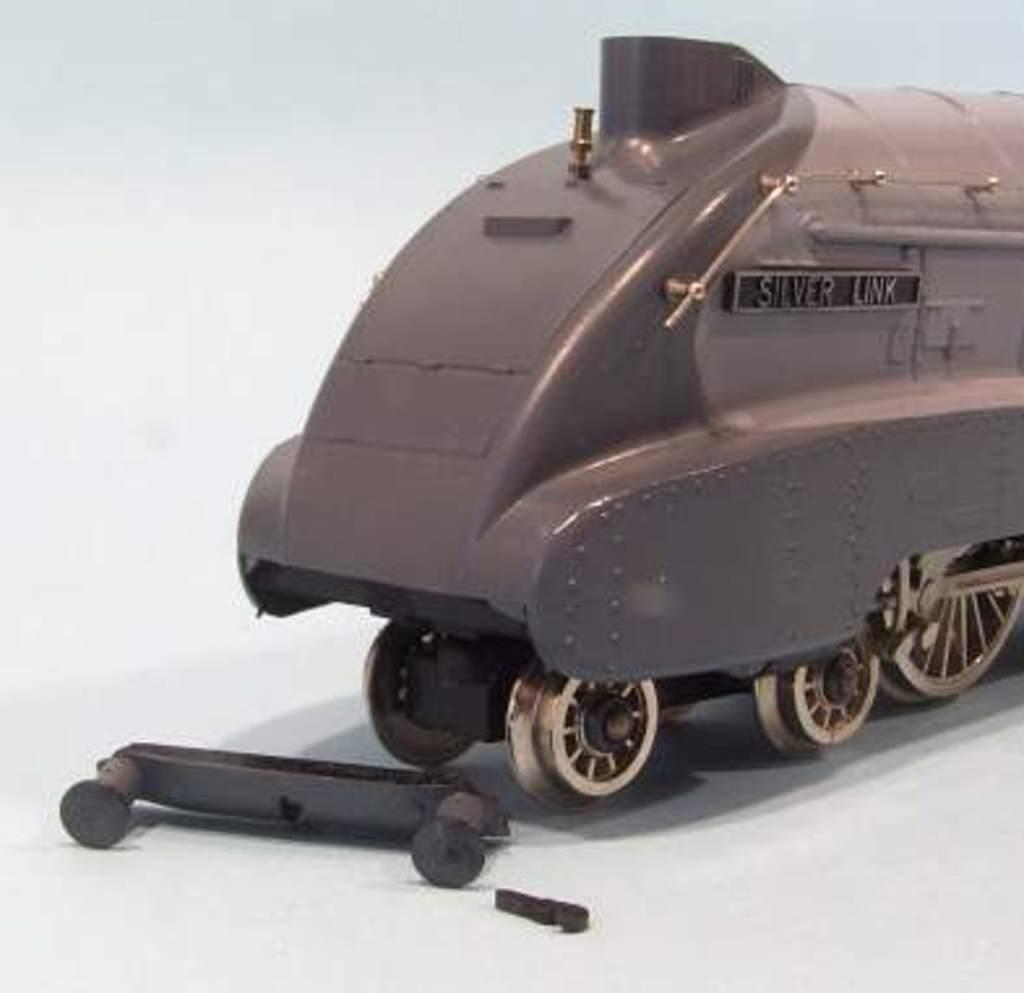What is the main subject of the image? The main subject of the image is an object that resembles a train. What feature does the object have? The object has wheels. What type of worm can be seen crawling on the train in the image? There is no worm present in the image; the main subject is an object that resembles a train with wheels. 